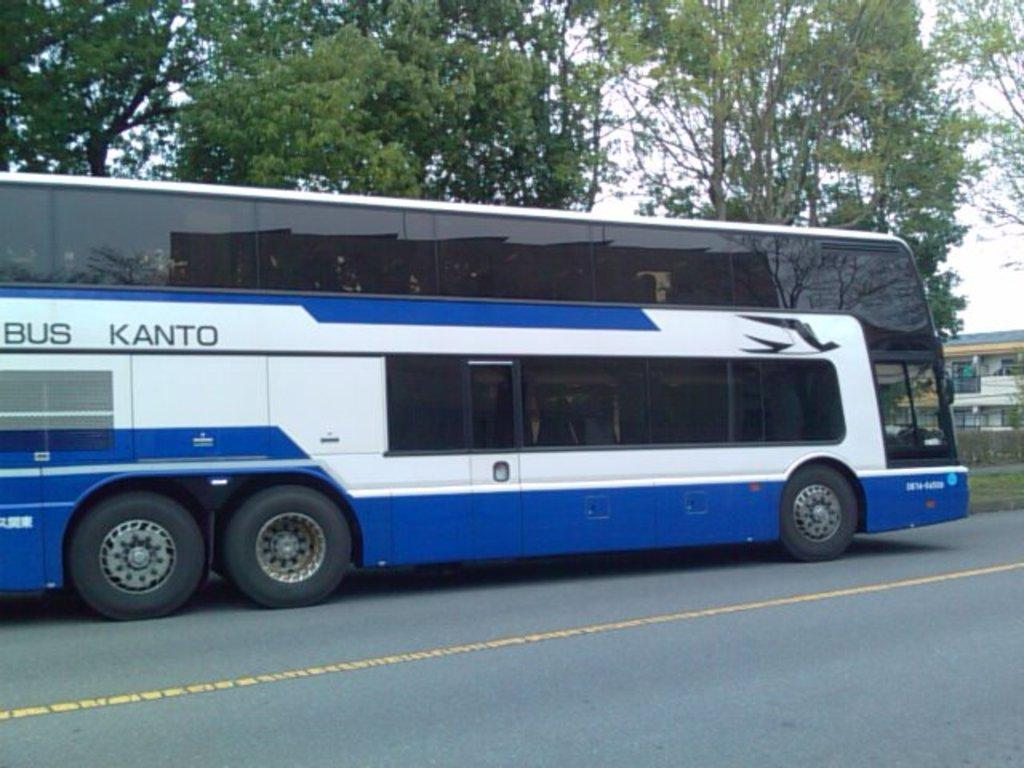What is the main subject of the image? The main subject of the image is a bus. Where is the bus located in the image? The bus is on the road in the image. What can be seen on the bus? There is writing on the bus. What type of natural environment is visible in the background of the image? Trees, grass, and the sky are visible in the background of the image. What type of man-made structures can be seen in the background of the image? There are buildings in the background of the image. Can you tell me how many pears are hanging from the basketball hoop in the image? There are no pears or basketball hoops present in the image. Is there an umbrella being used by the passengers on the bus in the image? There is no mention of passengers or an umbrella in the image; it only shows a bus on the road with writing on it. 